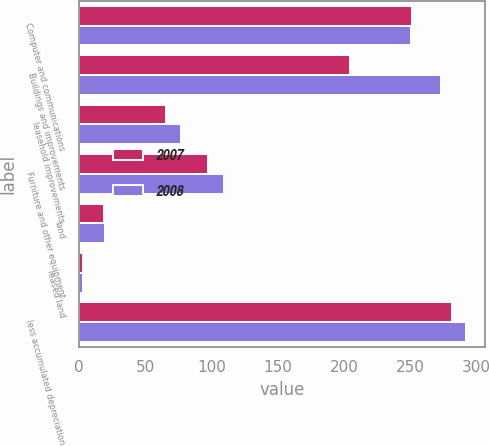Convert chart. <chart><loc_0><loc_0><loc_500><loc_500><stacked_bar_chart><ecel><fcel>Computer and communications<fcel>Buildings and improvements<fcel>leasehold improvements<fcel>Furniture and other equipment<fcel>land<fcel>leased land<fcel>less accumulated depreciation<nl><fcel>2007<fcel>251.5<fcel>204.2<fcel>65.8<fcel>97<fcel>18.8<fcel>2.7<fcel>281.7<nl><fcel>2008<fcel>250.6<fcel>272.8<fcel>76.5<fcel>109.6<fcel>19.7<fcel>2.7<fcel>291.8<nl></chart> 